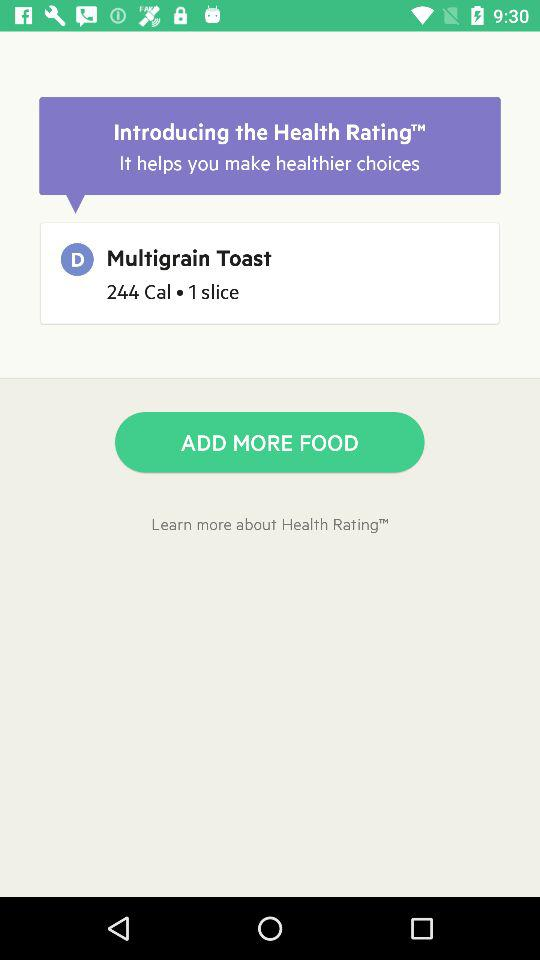How many calories are in 1 slice of multigrain toast?
Answer the question using a single word or phrase. 244 